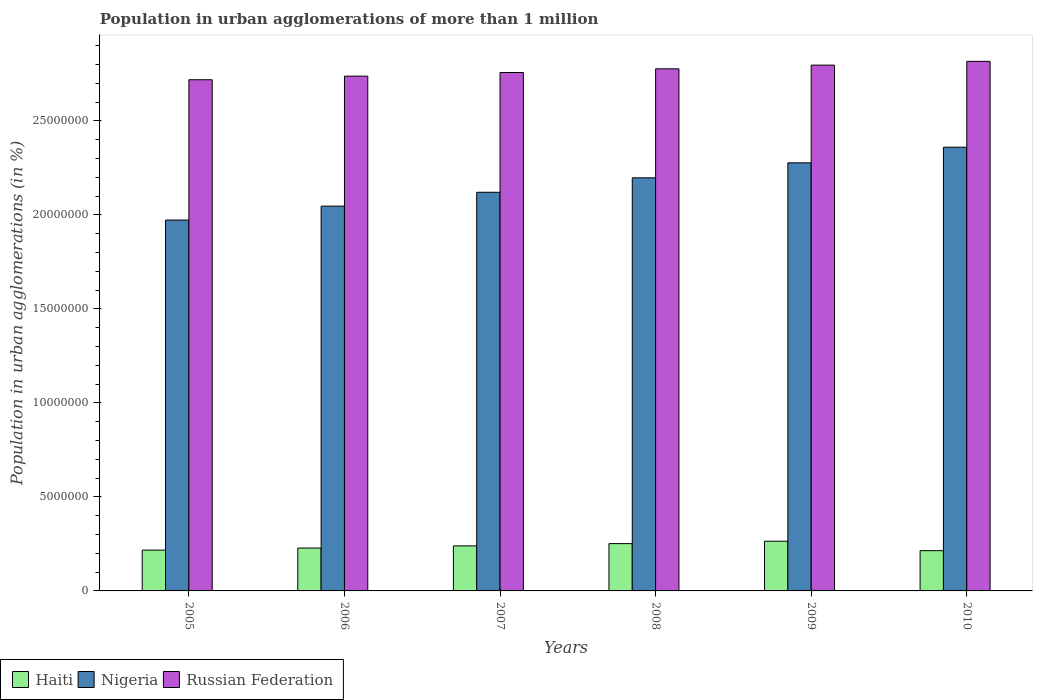How many groups of bars are there?
Keep it short and to the point. 6. Are the number of bars per tick equal to the number of legend labels?
Your answer should be very brief. Yes. How many bars are there on the 4th tick from the left?
Offer a very short reply. 3. What is the population in urban agglomerations in Nigeria in 2010?
Your answer should be very brief. 2.36e+07. Across all years, what is the maximum population in urban agglomerations in Russian Federation?
Ensure brevity in your answer.  2.82e+07. Across all years, what is the minimum population in urban agglomerations in Nigeria?
Keep it short and to the point. 1.97e+07. In which year was the population in urban agglomerations in Nigeria maximum?
Provide a succinct answer. 2010. What is the total population in urban agglomerations in Russian Federation in the graph?
Offer a terse response. 1.66e+08. What is the difference between the population in urban agglomerations in Haiti in 2006 and that in 2010?
Give a very brief answer. 1.39e+05. What is the difference between the population in urban agglomerations in Russian Federation in 2005 and the population in urban agglomerations in Haiti in 2009?
Ensure brevity in your answer.  2.45e+07. What is the average population in urban agglomerations in Nigeria per year?
Your answer should be compact. 2.16e+07. In the year 2009, what is the difference between the population in urban agglomerations in Russian Federation and population in urban agglomerations in Nigeria?
Give a very brief answer. 5.20e+06. What is the ratio of the population in urban agglomerations in Russian Federation in 2006 to that in 2010?
Keep it short and to the point. 0.97. What is the difference between the highest and the second highest population in urban agglomerations in Russian Federation?
Offer a terse response. 2.00e+05. What is the difference between the highest and the lowest population in urban agglomerations in Nigeria?
Your answer should be compact. 3.87e+06. In how many years, is the population in urban agglomerations in Haiti greater than the average population in urban agglomerations in Haiti taken over all years?
Give a very brief answer. 3. Is the sum of the population in urban agglomerations in Russian Federation in 2006 and 2010 greater than the maximum population in urban agglomerations in Haiti across all years?
Your response must be concise. Yes. What does the 1st bar from the left in 2008 represents?
Provide a short and direct response. Haiti. What does the 2nd bar from the right in 2006 represents?
Provide a short and direct response. Nigeria. Is it the case that in every year, the sum of the population in urban agglomerations in Nigeria and population in urban agglomerations in Haiti is greater than the population in urban agglomerations in Russian Federation?
Provide a short and direct response. No. How many bars are there?
Offer a terse response. 18. How many years are there in the graph?
Make the answer very short. 6. What is the difference between two consecutive major ticks on the Y-axis?
Your response must be concise. 5.00e+06. Are the values on the major ticks of Y-axis written in scientific E-notation?
Your response must be concise. No. What is the title of the graph?
Provide a succinct answer. Population in urban agglomerations of more than 1 million. Does "Suriname" appear as one of the legend labels in the graph?
Provide a short and direct response. No. What is the label or title of the Y-axis?
Offer a terse response. Population in urban agglomerations (in %). What is the Population in urban agglomerations (in %) in Haiti in 2005?
Offer a terse response. 2.17e+06. What is the Population in urban agglomerations (in %) in Nigeria in 2005?
Keep it short and to the point. 1.97e+07. What is the Population in urban agglomerations (in %) of Russian Federation in 2005?
Your answer should be very brief. 2.72e+07. What is the Population in urban agglomerations (in %) of Haiti in 2006?
Provide a short and direct response. 2.28e+06. What is the Population in urban agglomerations (in %) in Nigeria in 2006?
Give a very brief answer. 2.05e+07. What is the Population in urban agglomerations (in %) of Russian Federation in 2006?
Give a very brief answer. 2.74e+07. What is the Population in urban agglomerations (in %) of Haiti in 2007?
Ensure brevity in your answer.  2.40e+06. What is the Population in urban agglomerations (in %) in Nigeria in 2007?
Your answer should be very brief. 2.12e+07. What is the Population in urban agglomerations (in %) in Russian Federation in 2007?
Your answer should be compact. 2.76e+07. What is the Population in urban agglomerations (in %) in Haiti in 2008?
Your response must be concise. 2.52e+06. What is the Population in urban agglomerations (in %) in Nigeria in 2008?
Your response must be concise. 2.20e+07. What is the Population in urban agglomerations (in %) in Russian Federation in 2008?
Make the answer very short. 2.78e+07. What is the Population in urban agglomerations (in %) of Haiti in 2009?
Offer a very short reply. 2.64e+06. What is the Population in urban agglomerations (in %) in Nigeria in 2009?
Keep it short and to the point. 2.28e+07. What is the Population in urban agglomerations (in %) of Russian Federation in 2009?
Your answer should be compact. 2.80e+07. What is the Population in urban agglomerations (in %) of Haiti in 2010?
Make the answer very short. 2.14e+06. What is the Population in urban agglomerations (in %) of Nigeria in 2010?
Give a very brief answer. 2.36e+07. What is the Population in urban agglomerations (in %) in Russian Federation in 2010?
Your answer should be very brief. 2.82e+07. Across all years, what is the maximum Population in urban agglomerations (in %) of Haiti?
Ensure brevity in your answer.  2.64e+06. Across all years, what is the maximum Population in urban agglomerations (in %) of Nigeria?
Give a very brief answer. 2.36e+07. Across all years, what is the maximum Population in urban agglomerations (in %) in Russian Federation?
Give a very brief answer. 2.82e+07. Across all years, what is the minimum Population in urban agglomerations (in %) in Haiti?
Keep it short and to the point. 2.14e+06. Across all years, what is the minimum Population in urban agglomerations (in %) of Nigeria?
Your answer should be very brief. 1.97e+07. Across all years, what is the minimum Population in urban agglomerations (in %) of Russian Federation?
Make the answer very short. 2.72e+07. What is the total Population in urban agglomerations (in %) in Haiti in the graph?
Provide a short and direct response. 1.41e+07. What is the total Population in urban agglomerations (in %) of Nigeria in the graph?
Provide a short and direct response. 1.30e+08. What is the total Population in urban agglomerations (in %) of Russian Federation in the graph?
Your answer should be compact. 1.66e+08. What is the difference between the Population in urban agglomerations (in %) in Haiti in 2005 and that in 2006?
Provide a short and direct response. -1.09e+05. What is the difference between the Population in urban agglomerations (in %) of Nigeria in 2005 and that in 2006?
Keep it short and to the point. -7.40e+05. What is the difference between the Population in urban agglomerations (in %) of Russian Federation in 2005 and that in 2006?
Keep it short and to the point. -1.91e+05. What is the difference between the Population in urban agglomerations (in %) of Haiti in 2005 and that in 2007?
Give a very brief answer. -2.24e+05. What is the difference between the Population in urban agglomerations (in %) in Nigeria in 2005 and that in 2007?
Give a very brief answer. -1.48e+06. What is the difference between the Population in urban agglomerations (in %) of Russian Federation in 2005 and that in 2007?
Make the answer very short. -3.85e+05. What is the difference between the Population in urban agglomerations (in %) in Haiti in 2005 and that in 2008?
Ensure brevity in your answer.  -3.45e+05. What is the difference between the Population in urban agglomerations (in %) in Nigeria in 2005 and that in 2008?
Your response must be concise. -2.25e+06. What is the difference between the Population in urban agglomerations (in %) of Russian Federation in 2005 and that in 2008?
Provide a succinct answer. -5.81e+05. What is the difference between the Population in urban agglomerations (in %) in Haiti in 2005 and that in 2009?
Ensure brevity in your answer.  -4.72e+05. What is the difference between the Population in urban agglomerations (in %) in Nigeria in 2005 and that in 2009?
Offer a very short reply. -3.04e+06. What is the difference between the Population in urban agglomerations (in %) of Russian Federation in 2005 and that in 2009?
Ensure brevity in your answer.  -7.78e+05. What is the difference between the Population in urban agglomerations (in %) in Haiti in 2005 and that in 2010?
Give a very brief answer. 3.00e+04. What is the difference between the Population in urban agglomerations (in %) in Nigeria in 2005 and that in 2010?
Keep it short and to the point. -3.87e+06. What is the difference between the Population in urban agglomerations (in %) of Russian Federation in 2005 and that in 2010?
Keep it short and to the point. -9.78e+05. What is the difference between the Population in urban agglomerations (in %) of Haiti in 2006 and that in 2007?
Your response must be concise. -1.15e+05. What is the difference between the Population in urban agglomerations (in %) in Nigeria in 2006 and that in 2007?
Your answer should be compact. -7.38e+05. What is the difference between the Population in urban agglomerations (in %) in Russian Federation in 2006 and that in 2007?
Offer a very short reply. -1.93e+05. What is the difference between the Population in urban agglomerations (in %) in Haiti in 2006 and that in 2008?
Your response must be concise. -2.36e+05. What is the difference between the Population in urban agglomerations (in %) in Nigeria in 2006 and that in 2008?
Offer a very short reply. -1.51e+06. What is the difference between the Population in urban agglomerations (in %) of Russian Federation in 2006 and that in 2008?
Offer a very short reply. -3.89e+05. What is the difference between the Population in urban agglomerations (in %) in Haiti in 2006 and that in 2009?
Make the answer very short. -3.63e+05. What is the difference between the Population in urban agglomerations (in %) in Nigeria in 2006 and that in 2009?
Your answer should be compact. -2.30e+06. What is the difference between the Population in urban agglomerations (in %) of Russian Federation in 2006 and that in 2009?
Offer a very short reply. -5.87e+05. What is the difference between the Population in urban agglomerations (in %) in Haiti in 2006 and that in 2010?
Your answer should be compact. 1.39e+05. What is the difference between the Population in urban agglomerations (in %) in Nigeria in 2006 and that in 2010?
Provide a succinct answer. -3.13e+06. What is the difference between the Population in urban agglomerations (in %) of Russian Federation in 2006 and that in 2010?
Your response must be concise. -7.87e+05. What is the difference between the Population in urban agglomerations (in %) in Haiti in 2007 and that in 2008?
Offer a very short reply. -1.21e+05. What is the difference between the Population in urban agglomerations (in %) in Nigeria in 2007 and that in 2008?
Provide a succinct answer. -7.69e+05. What is the difference between the Population in urban agglomerations (in %) of Russian Federation in 2007 and that in 2008?
Make the answer very short. -1.96e+05. What is the difference between the Population in urban agglomerations (in %) of Haiti in 2007 and that in 2009?
Your response must be concise. -2.48e+05. What is the difference between the Population in urban agglomerations (in %) of Nigeria in 2007 and that in 2009?
Ensure brevity in your answer.  -1.57e+06. What is the difference between the Population in urban agglomerations (in %) of Russian Federation in 2007 and that in 2009?
Keep it short and to the point. -3.93e+05. What is the difference between the Population in urban agglomerations (in %) in Haiti in 2007 and that in 2010?
Offer a terse response. 2.54e+05. What is the difference between the Population in urban agglomerations (in %) of Nigeria in 2007 and that in 2010?
Give a very brief answer. -2.40e+06. What is the difference between the Population in urban agglomerations (in %) of Russian Federation in 2007 and that in 2010?
Offer a very short reply. -5.93e+05. What is the difference between the Population in urban agglomerations (in %) in Haiti in 2008 and that in 2009?
Your response must be concise. -1.27e+05. What is the difference between the Population in urban agglomerations (in %) of Nigeria in 2008 and that in 2009?
Offer a very short reply. -7.98e+05. What is the difference between the Population in urban agglomerations (in %) of Russian Federation in 2008 and that in 2009?
Offer a terse response. -1.98e+05. What is the difference between the Population in urban agglomerations (in %) in Haiti in 2008 and that in 2010?
Offer a terse response. 3.75e+05. What is the difference between the Population in urban agglomerations (in %) in Nigeria in 2008 and that in 2010?
Your response must be concise. -1.63e+06. What is the difference between the Population in urban agglomerations (in %) of Russian Federation in 2008 and that in 2010?
Provide a short and direct response. -3.98e+05. What is the difference between the Population in urban agglomerations (in %) in Haiti in 2009 and that in 2010?
Keep it short and to the point. 5.02e+05. What is the difference between the Population in urban agglomerations (in %) in Nigeria in 2009 and that in 2010?
Keep it short and to the point. -8.31e+05. What is the difference between the Population in urban agglomerations (in %) in Russian Federation in 2009 and that in 2010?
Give a very brief answer. -2.00e+05. What is the difference between the Population in urban agglomerations (in %) of Haiti in 2005 and the Population in urban agglomerations (in %) of Nigeria in 2006?
Ensure brevity in your answer.  -1.83e+07. What is the difference between the Population in urban agglomerations (in %) in Haiti in 2005 and the Population in urban agglomerations (in %) in Russian Federation in 2006?
Provide a succinct answer. -2.52e+07. What is the difference between the Population in urban agglomerations (in %) in Nigeria in 2005 and the Population in urban agglomerations (in %) in Russian Federation in 2006?
Ensure brevity in your answer.  -7.65e+06. What is the difference between the Population in urban agglomerations (in %) in Haiti in 2005 and the Population in urban agglomerations (in %) in Nigeria in 2007?
Your answer should be very brief. -1.90e+07. What is the difference between the Population in urban agglomerations (in %) in Haiti in 2005 and the Population in urban agglomerations (in %) in Russian Federation in 2007?
Provide a succinct answer. -2.54e+07. What is the difference between the Population in urban agglomerations (in %) of Nigeria in 2005 and the Population in urban agglomerations (in %) of Russian Federation in 2007?
Keep it short and to the point. -7.85e+06. What is the difference between the Population in urban agglomerations (in %) in Haiti in 2005 and the Population in urban agglomerations (in %) in Nigeria in 2008?
Ensure brevity in your answer.  -1.98e+07. What is the difference between the Population in urban agglomerations (in %) of Haiti in 2005 and the Population in urban agglomerations (in %) of Russian Federation in 2008?
Ensure brevity in your answer.  -2.56e+07. What is the difference between the Population in urban agglomerations (in %) in Nigeria in 2005 and the Population in urban agglomerations (in %) in Russian Federation in 2008?
Provide a succinct answer. -8.04e+06. What is the difference between the Population in urban agglomerations (in %) in Haiti in 2005 and the Population in urban agglomerations (in %) in Nigeria in 2009?
Provide a short and direct response. -2.06e+07. What is the difference between the Population in urban agglomerations (in %) in Haiti in 2005 and the Population in urban agglomerations (in %) in Russian Federation in 2009?
Provide a short and direct response. -2.58e+07. What is the difference between the Population in urban agglomerations (in %) of Nigeria in 2005 and the Population in urban agglomerations (in %) of Russian Federation in 2009?
Give a very brief answer. -8.24e+06. What is the difference between the Population in urban agglomerations (in %) in Haiti in 2005 and the Population in urban agglomerations (in %) in Nigeria in 2010?
Keep it short and to the point. -2.14e+07. What is the difference between the Population in urban agglomerations (in %) in Haiti in 2005 and the Population in urban agglomerations (in %) in Russian Federation in 2010?
Your response must be concise. -2.60e+07. What is the difference between the Population in urban agglomerations (in %) in Nigeria in 2005 and the Population in urban agglomerations (in %) in Russian Federation in 2010?
Your response must be concise. -8.44e+06. What is the difference between the Population in urban agglomerations (in %) in Haiti in 2006 and the Population in urban agglomerations (in %) in Nigeria in 2007?
Offer a very short reply. -1.89e+07. What is the difference between the Population in urban agglomerations (in %) of Haiti in 2006 and the Population in urban agglomerations (in %) of Russian Federation in 2007?
Provide a succinct answer. -2.53e+07. What is the difference between the Population in urban agglomerations (in %) in Nigeria in 2006 and the Population in urban agglomerations (in %) in Russian Federation in 2007?
Your response must be concise. -7.11e+06. What is the difference between the Population in urban agglomerations (in %) in Haiti in 2006 and the Population in urban agglomerations (in %) in Nigeria in 2008?
Offer a terse response. -1.97e+07. What is the difference between the Population in urban agglomerations (in %) in Haiti in 2006 and the Population in urban agglomerations (in %) in Russian Federation in 2008?
Provide a succinct answer. -2.55e+07. What is the difference between the Population in urban agglomerations (in %) of Nigeria in 2006 and the Population in urban agglomerations (in %) of Russian Federation in 2008?
Ensure brevity in your answer.  -7.30e+06. What is the difference between the Population in urban agglomerations (in %) in Haiti in 2006 and the Population in urban agglomerations (in %) in Nigeria in 2009?
Ensure brevity in your answer.  -2.05e+07. What is the difference between the Population in urban agglomerations (in %) of Haiti in 2006 and the Population in urban agglomerations (in %) of Russian Federation in 2009?
Ensure brevity in your answer.  -2.57e+07. What is the difference between the Population in urban agglomerations (in %) in Nigeria in 2006 and the Population in urban agglomerations (in %) in Russian Federation in 2009?
Offer a very short reply. -7.50e+06. What is the difference between the Population in urban agglomerations (in %) in Haiti in 2006 and the Population in urban agglomerations (in %) in Nigeria in 2010?
Your answer should be compact. -2.13e+07. What is the difference between the Population in urban agglomerations (in %) in Haiti in 2006 and the Population in urban agglomerations (in %) in Russian Federation in 2010?
Ensure brevity in your answer.  -2.59e+07. What is the difference between the Population in urban agglomerations (in %) of Nigeria in 2006 and the Population in urban agglomerations (in %) of Russian Federation in 2010?
Provide a short and direct response. -7.70e+06. What is the difference between the Population in urban agglomerations (in %) in Haiti in 2007 and the Population in urban agglomerations (in %) in Nigeria in 2008?
Ensure brevity in your answer.  -1.96e+07. What is the difference between the Population in urban agglomerations (in %) of Haiti in 2007 and the Population in urban agglomerations (in %) of Russian Federation in 2008?
Keep it short and to the point. -2.54e+07. What is the difference between the Population in urban agglomerations (in %) in Nigeria in 2007 and the Population in urban agglomerations (in %) in Russian Federation in 2008?
Offer a terse response. -6.57e+06. What is the difference between the Population in urban agglomerations (in %) of Haiti in 2007 and the Population in urban agglomerations (in %) of Nigeria in 2009?
Your answer should be compact. -2.04e+07. What is the difference between the Population in urban agglomerations (in %) in Haiti in 2007 and the Population in urban agglomerations (in %) in Russian Federation in 2009?
Make the answer very short. -2.56e+07. What is the difference between the Population in urban agglomerations (in %) of Nigeria in 2007 and the Population in urban agglomerations (in %) of Russian Federation in 2009?
Keep it short and to the point. -6.76e+06. What is the difference between the Population in urban agglomerations (in %) of Haiti in 2007 and the Population in urban agglomerations (in %) of Nigeria in 2010?
Provide a succinct answer. -2.12e+07. What is the difference between the Population in urban agglomerations (in %) in Haiti in 2007 and the Population in urban agglomerations (in %) in Russian Federation in 2010?
Ensure brevity in your answer.  -2.58e+07. What is the difference between the Population in urban agglomerations (in %) of Nigeria in 2007 and the Population in urban agglomerations (in %) of Russian Federation in 2010?
Your answer should be compact. -6.96e+06. What is the difference between the Population in urban agglomerations (in %) in Haiti in 2008 and the Population in urban agglomerations (in %) in Nigeria in 2009?
Keep it short and to the point. -2.03e+07. What is the difference between the Population in urban agglomerations (in %) of Haiti in 2008 and the Population in urban agglomerations (in %) of Russian Federation in 2009?
Your answer should be compact. -2.54e+07. What is the difference between the Population in urban agglomerations (in %) of Nigeria in 2008 and the Population in urban agglomerations (in %) of Russian Federation in 2009?
Provide a short and direct response. -5.99e+06. What is the difference between the Population in urban agglomerations (in %) of Haiti in 2008 and the Population in urban agglomerations (in %) of Nigeria in 2010?
Give a very brief answer. -2.11e+07. What is the difference between the Population in urban agglomerations (in %) in Haiti in 2008 and the Population in urban agglomerations (in %) in Russian Federation in 2010?
Your answer should be very brief. -2.56e+07. What is the difference between the Population in urban agglomerations (in %) in Nigeria in 2008 and the Population in urban agglomerations (in %) in Russian Federation in 2010?
Make the answer very short. -6.19e+06. What is the difference between the Population in urban agglomerations (in %) of Haiti in 2009 and the Population in urban agglomerations (in %) of Nigeria in 2010?
Your answer should be compact. -2.10e+07. What is the difference between the Population in urban agglomerations (in %) in Haiti in 2009 and the Population in urban agglomerations (in %) in Russian Federation in 2010?
Provide a succinct answer. -2.55e+07. What is the difference between the Population in urban agglomerations (in %) in Nigeria in 2009 and the Population in urban agglomerations (in %) in Russian Federation in 2010?
Ensure brevity in your answer.  -5.40e+06. What is the average Population in urban agglomerations (in %) in Haiti per year?
Your response must be concise. 2.36e+06. What is the average Population in urban agglomerations (in %) in Nigeria per year?
Your answer should be compact. 2.16e+07. What is the average Population in urban agglomerations (in %) of Russian Federation per year?
Ensure brevity in your answer.  2.77e+07. In the year 2005, what is the difference between the Population in urban agglomerations (in %) of Haiti and Population in urban agglomerations (in %) of Nigeria?
Provide a short and direct response. -1.76e+07. In the year 2005, what is the difference between the Population in urban agglomerations (in %) of Haiti and Population in urban agglomerations (in %) of Russian Federation?
Give a very brief answer. -2.50e+07. In the year 2005, what is the difference between the Population in urban agglomerations (in %) of Nigeria and Population in urban agglomerations (in %) of Russian Federation?
Make the answer very short. -7.46e+06. In the year 2006, what is the difference between the Population in urban agglomerations (in %) of Haiti and Population in urban agglomerations (in %) of Nigeria?
Ensure brevity in your answer.  -1.82e+07. In the year 2006, what is the difference between the Population in urban agglomerations (in %) of Haiti and Population in urban agglomerations (in %) of Russian Federation?
Provide a short and direct response. -2.51e+07. In the year 2006, what is the difference between the Population in urban agglomerations (in %) of Nigeria and Population in urban agglomerations (in %) of Russian Federation?
Offer a very short reply. -6.91e+06. In the year 2007, what is the difference between the Population in urban agglomerations (in %) of Haiti and Population in urban agglomerations (in %) of Nigeria?
Make the answer very short. -1.88e+07. In the year 2007, what is the difference between the Population in urban agglomerations (in %) of Haiti and Population in urban agglomerations (in %) of Russian Federation?
Provide a short and direct response. -2.52e+07. In the year 2007, what is the difference between the Population in urban agglomerations (in %) of Nigeria and Population in urban agglomerations (in %) of Russian Federation?
Your answer should be very brief. -6.37e+06. In the year 2008, what is the difference between the Population in urban agglomerations (in %) in Haiti and Population in urban agglomerations (in %) in Nigeria?
Make the answer very short. -1.95e+07. In the year 2008, what is the difference between the Population in urban agglomerations (in %) of Haiti and Population in urban agglomerations (in %) of Russian Federation?
Give a very brief answer. -2.53e+07. In the year 2008, what is the difference between the Population in urban agglomerations (in %) in Nigeria and Population in urban agglomerations (in %) in Russian Federation?
Offer a very short reply. -5.80e+06. In the year 2009, what is the difference between the Population in urban agglomerations (in %) of Haiti and Population in urban agglomerations (in %) of Nigeria?
Offer a very short reply. -2.01e+07. In the year 2009, what is the difference between the Population in urban agglomerations (in %) of Haiti and Population in urban agglomerations (in %) of Russian Federation?
Provide a succinct answer. -2.53e+07. In the year 2009, what is the difference between the Population in urban agglomerations (in %) of Nigeria and Population in urban agglomerations (in %) of Russian Federation?
Your response must be concise. -5.20e+06. In the year 2010, what is the difference between the Population in urban agglomerations (in %) in Haiti and Population in urban agglomerations (in %) in Nigeria?
Ensure brevity in your answer.  -2.15e+07. In the year 2010, what is the difference between the Population in urban agglomerations (in %) of Haiti and Population in urban agglomerations (in %) of Russian Federation?
Offer a very short reply. -2.60e+07. In the year 2010, what is the difference between the Population in urban agglomerations (in %) in Nigeria and Population in urban agglomerations (in %) in Russian Federation?
Provide a succinct answer. -4.57e+06. What is the ratio of the Population in urban agglomerations (in %) in Nigeria in 2005 to that in 2006?
Offer a very short reply. 0.96. What is the ratio of the Population in urban agglomerations (in %) of Russian Federation in 2005 to that in 2006?
Make the answer very short. 0.99. What is the ratio of the Population in urban agglomerations (in %) of Haiti in 2005 to that in 2007?
Offer a very short reply. 0.91. What is the ratio of the Population in urban agglomerations (in %) of Nigeria in 2005 to that in 2007?
Make the answer very short. 0.93. What is the ratio of the Population in urban agglomerations (in %) of Haiti in 2005 to that in 2008?
Make the answer very short. 0.86. What is the ratio of the Population in urban agglomerations (in %) of Nigeria in 2005 to that in 2008?
Your answer should be compact. 0.9. What is the ratio of the Population in urban agglomerations (in %) in Russian Federation in 2005 to that in 2008?
Ensure brevity in your answer.  0.98. What is the ratio of the Population in urban agglomerations (in %) in Haiti in 2005 to that in 2009?
Offer a very short reply. 0.82. What is the ratio of the Population in urban agglomerations (in %) of Nigeria in 2005 to that in 2009?
Your response must be concise. 0.87. What is the ratio of the Population in urban agglomerations (in %) in Russian Federation in 2005 to that in 2009?
Your response must be concise. 0.97. What is the ratio of the Population in urban agglomerations (in %) of Haiti in 2005 to that in 2010?
Make the answer very short. 1.01. What is the ratio of the Population in urban agglomerations (in %) of Nigeria in 2005 to that in 2010?
Your response must be concise. 0.84. What is the ratio of the Population in urban agglomerations (in %) in Russian Federation in 2005 to that in 2010?
Offer a terse response. 0.97. What is the ratio of the Population in urban agglomerations (in %) of Nigeria in 2006 to that in 2007?
Offer a terse response. 0.97. What is the ratio of the Population in urban agglomerations (in %) of Haiti in 2006 to that in 2008?
Your answer should be very brief. 0.91. What is the ratio of the Population in urban agglomerations (in %) in Nigeria in 2006 to that in 2008?
Provide a short and direct response. 0.93. What is the ratio of the Population in urban agglomerations (in %) of Haiti in 2006 to that in 2009?
Give a very brief answer. 0.86. What is the ratio of the Population in urban agglomerations (in %) of Nigeria in 2006 to that in 2009?
Give a very brief answer. 0.9. What is the ratio of the Population in urban agglomerations (in %) in Russian Federation in 2006 to that in 2009?
Your answer should be very brief. 0.98. What is the ratio of the Population in urban agglomerations (in %) of Haiti in 2006 to that in 2010?
Your response must be concise. 1.07. What is the ratio of the Population in urban agglomerations (in %) in Nigeria in 2006 to that in 2010?
Provide a succinct answer. 0.87. What is the ratio of the Population in urban agglomerations (in %) in Russian Federation in 2006 to that in 2010?
Your answer should be compact. 0.97. What is the ratio of the Population in urban agglomerations (in %) in Haiti in 2007 to that in 2008?
Offer a very short reply. 0.95. What is the ratio of the Population in urban agglomerations (in %) of Nigeria in 2007 to that in 2008?
Offer a very short reply. 0.96. What is the ratio of the Population in urban agglomerations (in %) of Haiti in 2007 to that in 2009?
Your answer should be compact. 0.91. What is the ratio of the Population in urban agglomerations (in %) of Nigeria in 2007 to that in 2009?
Give a very brief answer. 0.93. What is the ratio of the Population in urban agglomerations (in %) in Russian Federation in 2007 to that in 2009?
Your answer should be compact. 0.99. What is the ratio of the Population in urban agglomerations (in %) in Haiti in 2007 to that in 2010?
Provide a succinct answer. 1.12. What is the ratio of the Population in urban agglomerations (in %) in Nigeria in 2007 to that in 2010?
Give a very brief answer. 0.9. What is the ratio of the Population in urban agglomerations (in %) of Russian Federation in 2007 to that in 2010?
Give a very brief answer. 0.98. What is the ratio of the Population in urban agglomerations (in %) of Haiti in 2008 to that in 2009?
Your answer should be compact. 0.95. What is the ratio of the Population in urban agglomerations (in %) in Haiti in 2008 to that in 2010?
Provide a short and direct response. 1.18. What is the ratio of the Population in urban agglomerations (in %) of Russian Federation in 2008 to that in 2010?
Ensure brevity in your answer.  0.99. What is the ratio of the Population in urban agglomerations (in %) in Haiti in 2009 to that in 2010?
Your answer should be very brief. 1.23. What is the ratio of the Population in urban agglomerations (in %) of Nigeria in 2009 to that in 2010?
Provide a short and direct response. 0.96. What is the difference between the highest and the second highest Population in urban agglomerations (in %) of Haiti?
Provide a succinct answer. 1.27e+05. What is the difference between the highest and the second highest Population in urban agglomerations (in %) in Nigeria?
Keep it short and to the point. 8.31e+05. What is the difference between the highest and the second highest Population in urban agglomerations (in %) in Russian Federation?
Your answer should be very brief. 2.00e+05. What is the difference between the highest and the lowest Population in urban agglomerations (in %) in Haiti?
Give a very brief answer. 5.02e+05. What is the difference between the highest and the lowest Population in urban agglomerations (in %) in Nigeria?
Offer a terse response. 3.87e+06. What is the difference between the highest and the lowest Population in urban agglomerations (in %) in Russian Federation?
Keep it short and to the point. 9.78e+05. 